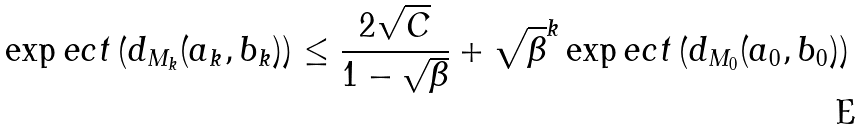<formula> <loc_0><loc_0><loc_500><loc_500>\exp e c t \left ( d _ { M _ { k } } ( a _ { k } , b _ { k } ) \right ) \leq \frac { 2 \sqrt { C } } { 1 - \sqrt { \beta } } + \sqrt { \beta } ^ { k } \exp e c t \left ( d _ { M _ { 0 } } ( a _ { 0 } , b _ { 0 } ) \right )</formula> 